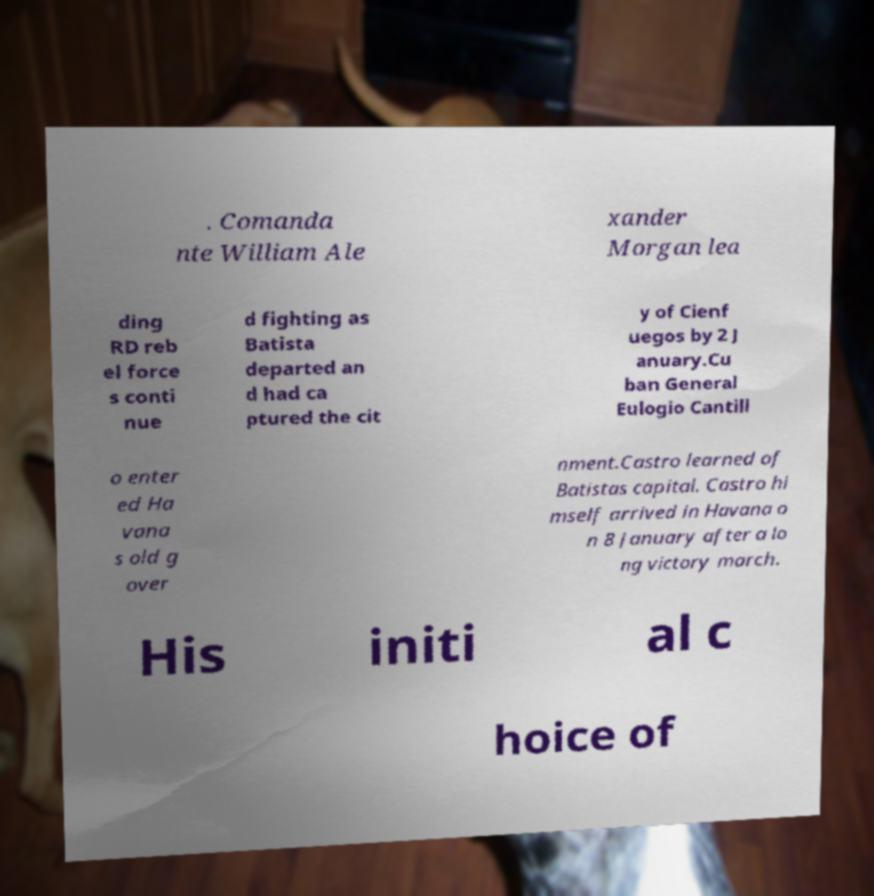Could you assist in decoding the text presented in this image and type it out clearly? . Comanda nte William Ale xander Morgan lea ding RD reb el force s conti nue d fighting as Batista departed an d had ca ptured the cit y of Cienf uegos by 2 J anuary.Cu ban General Eulogio Cantill o enter ed Ha vana s old g over nment.Castro learned of Batistas capital. Castro hi mself arrived in Havana o n 8 January after a lo ng victory march. His initi al c hoice of 